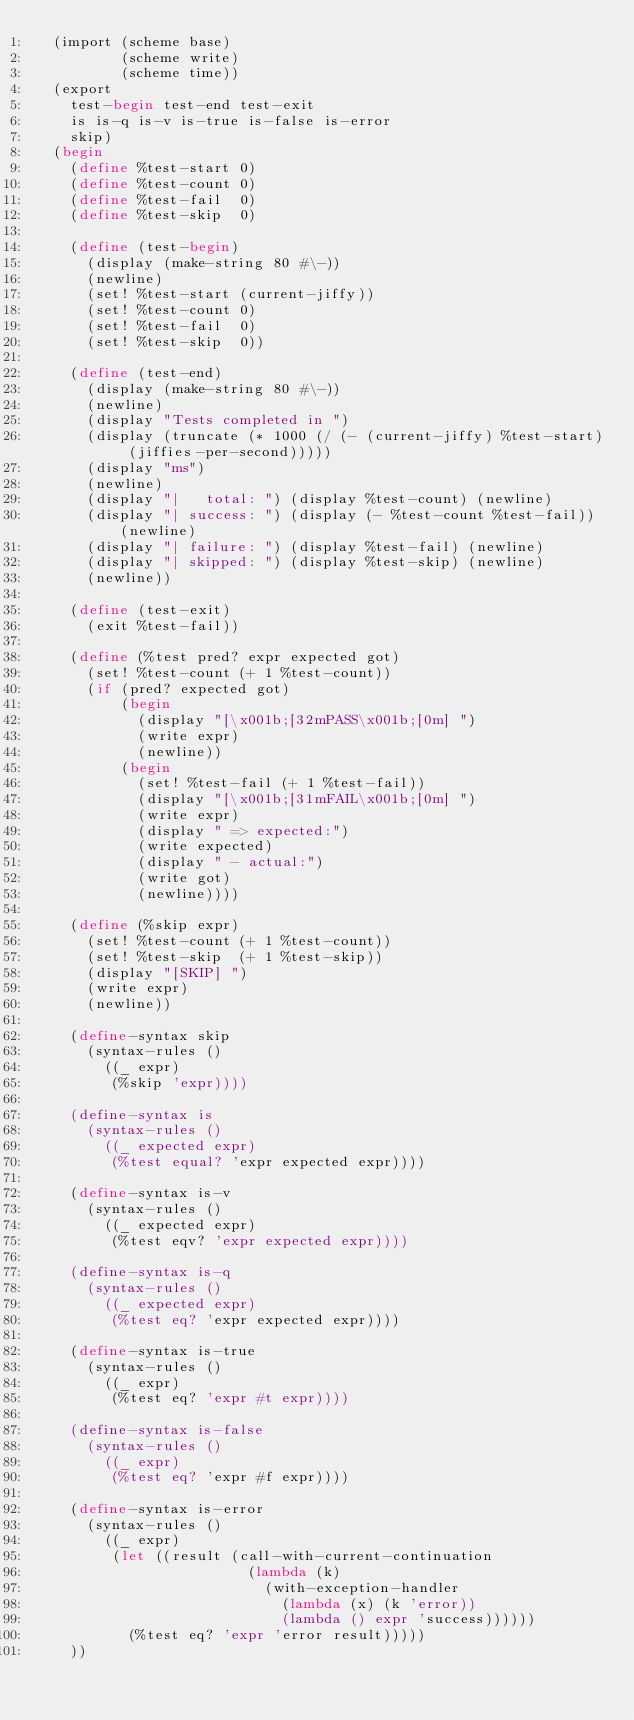<code> <loc_0><loc_0><loc_500><loc_500><_Scheme_>  (import (scheme base)
          (scheme write)
          (scheme time))
  (export
    test-begin test-end test-exit
    is is-q is-v is-true is-false is-error
    skip)
  (begin
    (define %test-start 0)
    (define %test-count 0)
    (define %test-fail  0)
    (define %test-skip  0)

    (define (test-begin)
      (display (make-string 80 #\-))
      (newline)
      (set! %test-start (current-jiffy))
      (set! %test-count 0)
      (set! %test-fail  0)
      (set! %test-skip  0))

    (define (test-end)
      (display (make-string 80 #\-))
      (newline)
      (display "Tests completed in ")
      (display (truncate (* 1000 (/ (- (current-jiffy) %test-start) (jiffies-per-second)))))
      (display "ms")
      (newline)
      (display "|   total: ") (display %test-count) (newline)
      (display "| success: ") (display (- %test-count %test-fail)) (newline)
      (display "| failure: ") (display %test-fail) (newline)
      (display "| skipped: ") (display %test-skip) (newline)
      (newline))

    (define (test-exit)
      (exit %test-fail))

    (define (%test pred? expr expected got)
      (set! %test-count (+ 1 %test-count))
      (if (pred? expected got)
          (begin
            (display "[\x001b;[32mPASS\x001b;[0m] ")
            (write expr)
            (newline))
          (begin
            (set! %test-fail (+ 1 %test-fail))
            (display "[\x001b;[31mFAIL\x001b;[0m] ")
            (write expr)
            (display " => expected:")
            (write expected)
            (display " - actual:")
            (write got)
            (newline))))

    (define (%skip expr)
      (set! %test-count (+ 1 %test-count))
      (set! %test-skip  (+ 1 %test-skip))
      (display "[SKIP] ")
      (write expr)
      (newline))

    (define-syntax skip
      (syntax-rules ()
        ((_ expr)
         (%skip 'expr))))

    (define-syntax is
      (syntax-rules ()
        ((_ expected expr)
         (%test equal? 'expr expected expr))))

    (define-syntax is-v
      (syntax-rules ()
        ((_ expected expr)
         (%test eqv? 'expr expected expr))))

    (define-syntax is-q
      (syntax-rules ()
        ((_ expected expr)
         (%test eq? 'expr expected expr))))
    
    (define-syntax is-true
      (syntax-rules ()
        ((_ expr)
         (%test eq? 'expr #t expr))))

    (define-syntax is-false
      (syntax-rules ()
        ((_ expr)
         (%test eq? 'expr #f expr))))

    (define-syntax is-error
      (syntax-rules ()
        ((_ expr)
         (let ((result (call-with-current-continuation
                         (lambda (k)
                           (with-exception-handler
                             (lambda (x) (k 'error))
                             (lambda () expr 'success))))))
           (%test eq? 'expr 'error result)))))
    ))

</code> 